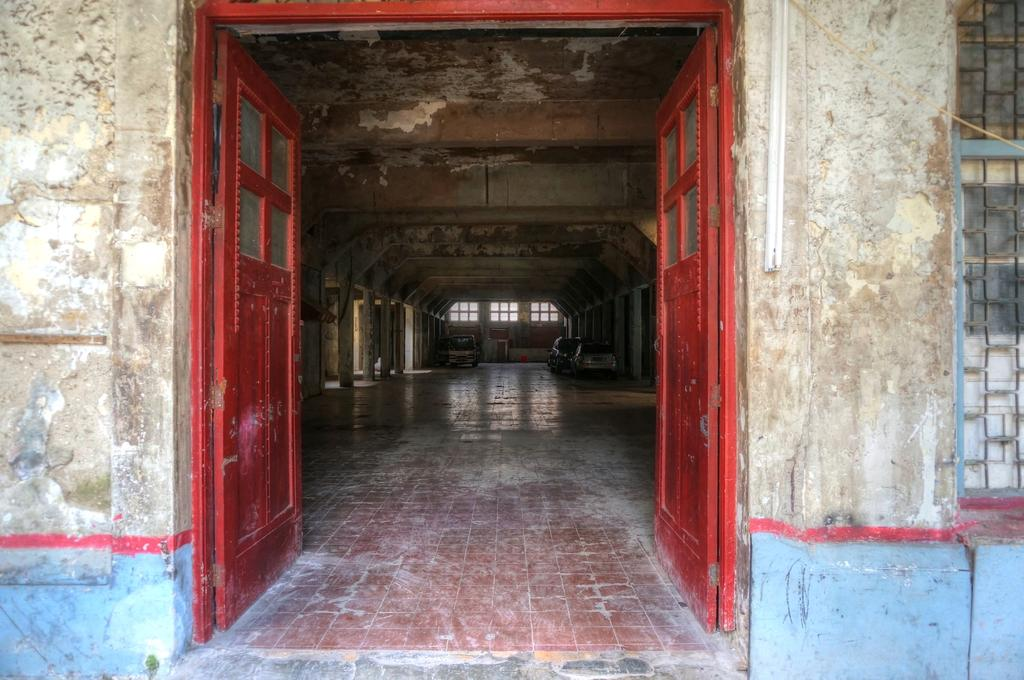What color are the doors in the image? The doors in the image are red. What purpose do the red doors serve? The red doors are the entrance to a building. Can you describe any other architectural features in the image? There is a window on the wall in the back of the image, and there are pillars on either side of the hall. What type of farm can be seen in the image? There is no farm present in the image; it features red doors as the entrance to a building. What kind of peace is being promoted in the image? The image does not depict any peace-related content or message. 